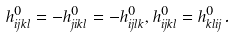<formula> <loc_0><loc_0><loc_500><loc_500>& h _ { i j k l } ^ { 0 } = - h _ { j i k l } ^ { 0 } = - h _ { i j l k } ^ { 0 } , h _ { i j k l } ^ { 0 } = h _ { k l i j } ^ { 0 } .</formula> 